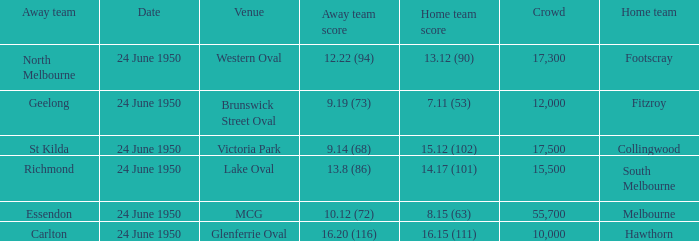When was the game where the away team had a score of 13.8 (86)? 24 June 1950. 